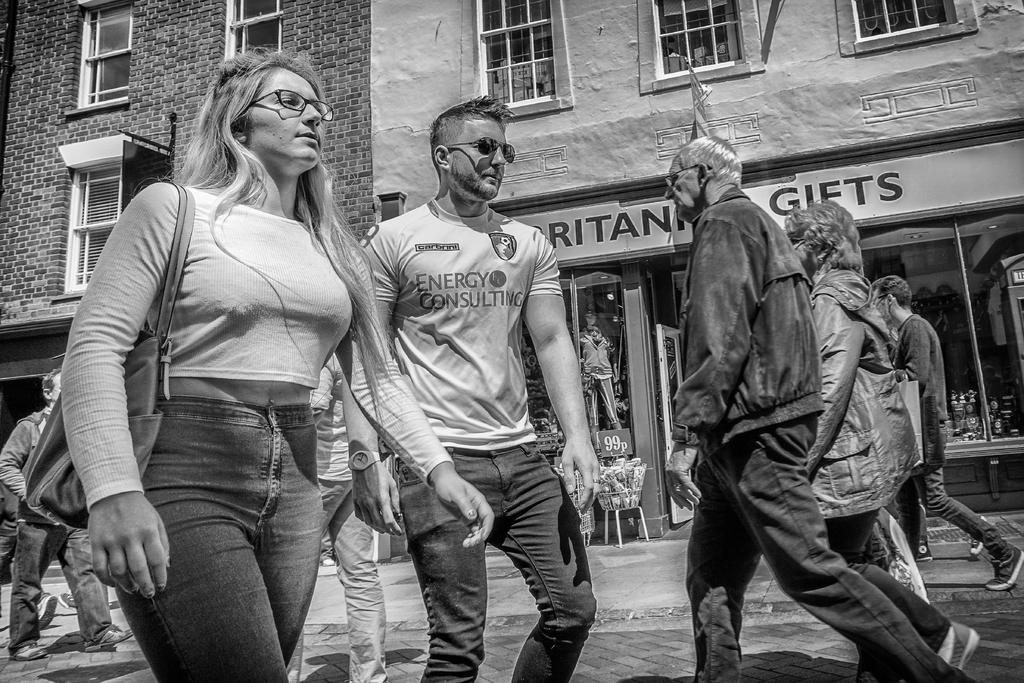What is the color scheme of the image? The image is black and white. What are the people in the image doing? The people in the image are walking. Can you describe the woman's attire in the image? The woman is wearing a bag. What can be seen in the background of the image? There is a building, windows, and glass visible in the background of the image. Can you tell me how many bricks are visible in the image? There are no bricks visible in the image; it is a black and white image with people walking and a woman wearing a bag. What type of toad can be seen interacting with the woman in the image? There is no toad present in the image; it only features people walking and a woman wearing a bag. 